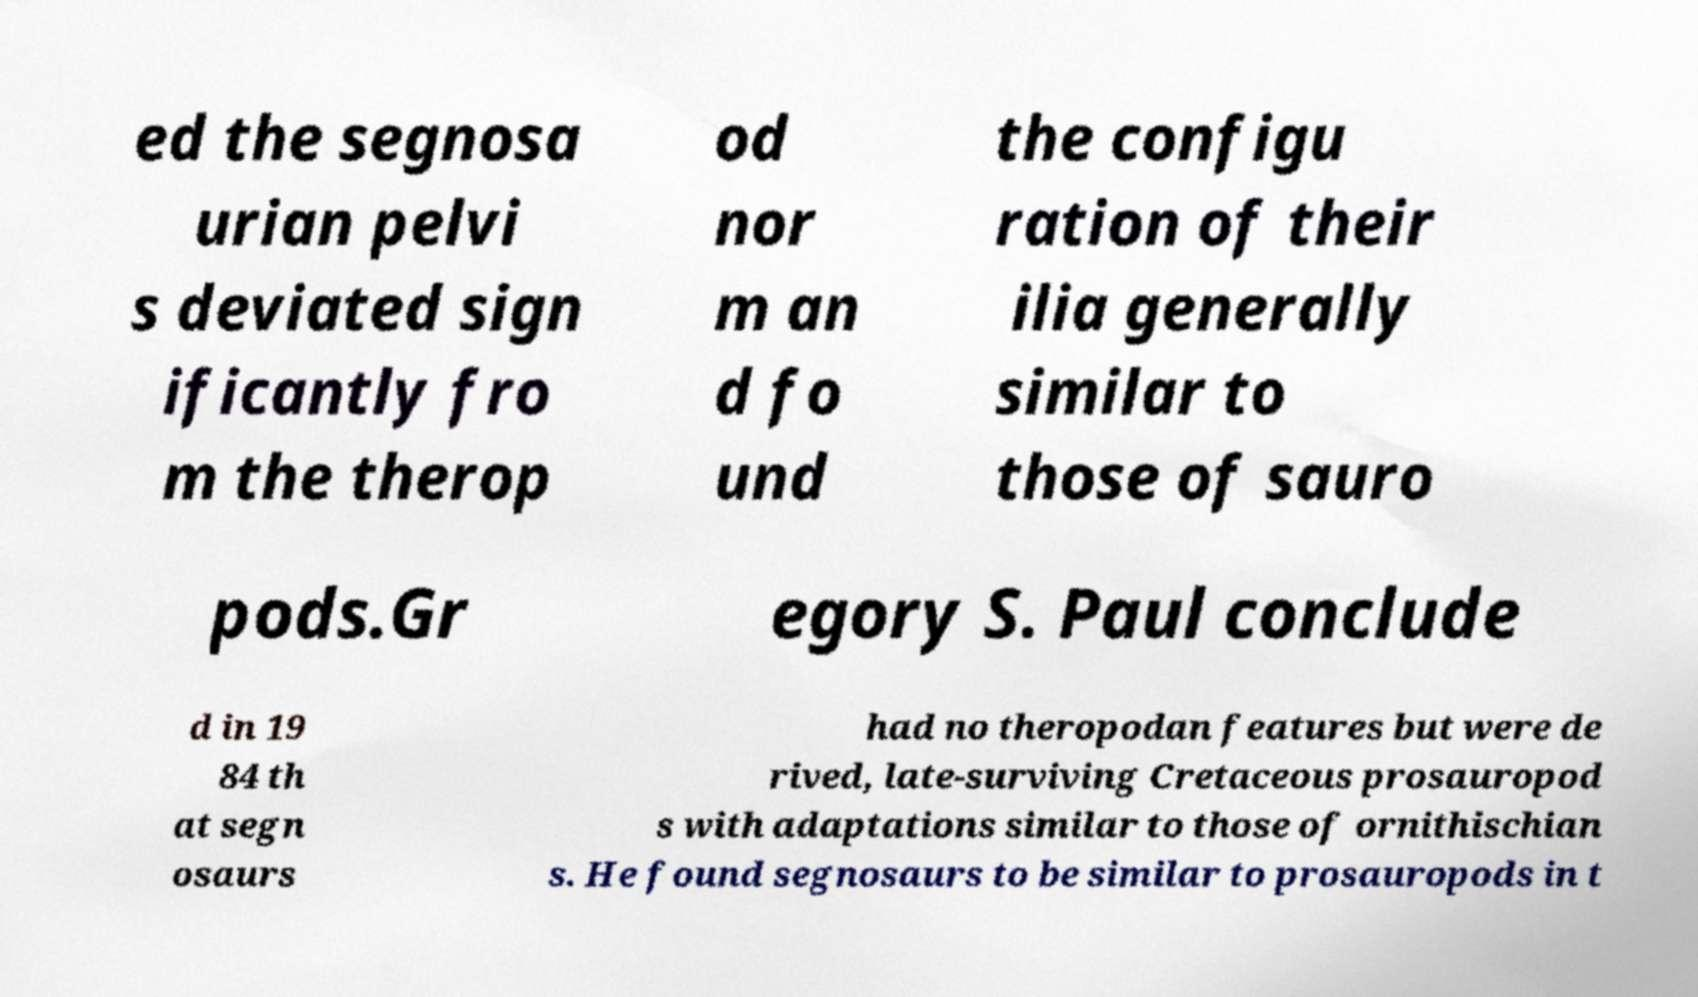There's text embedded in this image that I need extracted. Can you transcribe it verbatim? ed the segnosa urian pelvi s deviated sign ificantly fro m the therop od nor m an d fo und the configu ration of their ilia generally similar to those of sauro pods.Gr egory S. Paul conclude d in 19 84 th at segn osaurs had no theropodan features but were de rived, late-surviving Cretaceous prosauropod s with adaptations similar to those of ornithischian s. He found segnosaurs to be similar to prosauropods in t 